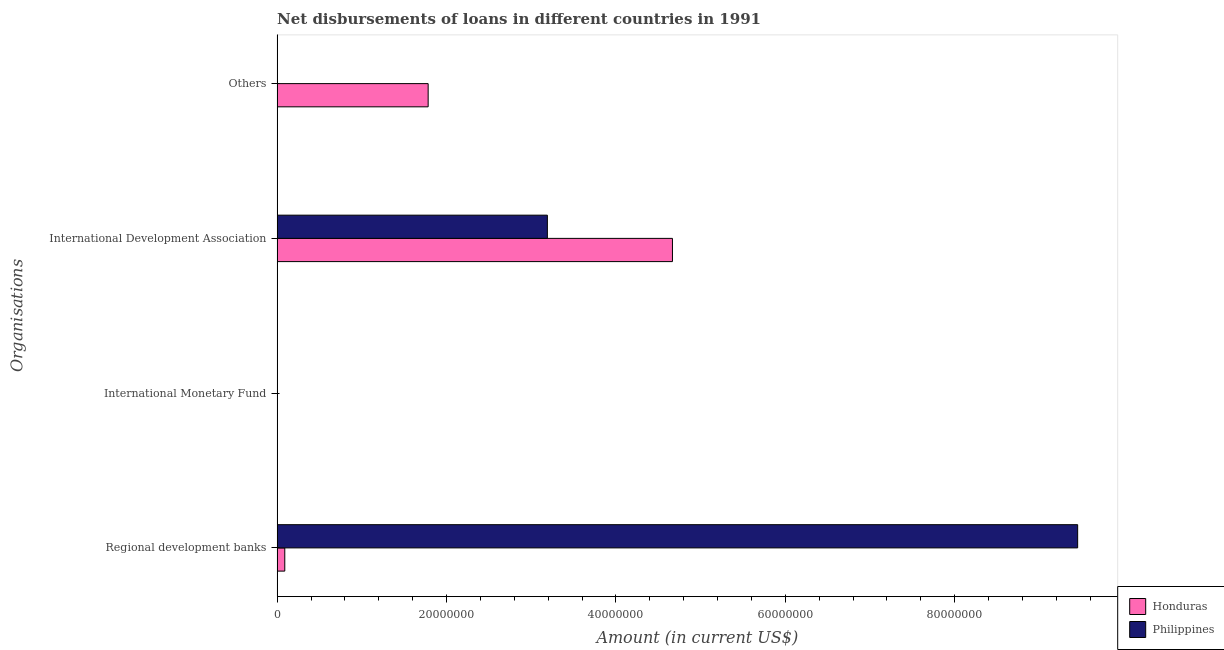How many different coloured bars are there?
Your answer should be compact. 2. Are the number of bars per tick equal to the number of legend labels?
Ensure brevity in your answer.  No. Are the number of bars on each tick of the Y-axis equal?
Your response must be concise. No. How many bars are there on the 3rd tick from the top?
Provide a succinct answer. 0. What is the label of the 4th group of bars from the top?
Keep it short and to the point. Regional development banks. What is the amount of loan disimbursed by international development association in Honduras?
Ensure brevity in your answer.  4.67e+07. Across all countries, what is the maximum amount of loan disimbursed by regional development banks?
Offer a very short reply. 9.45e+07. Across all countries, what is the minimum amount of loan disimbursed by international monetary fund?
Offer a terse response. 0. In which country was the amount of loan disimbursed by international development association maximum?
Your answer should be very brief. Honduras. What is the total amount of loan disimbursed by international monetary fund in the graph?
Provide a short and direct response. 0. What is the difference between the amount of loan disimbursed by regional development banks in Honduras and that in Philippines?
Provide a succinct answer. -9.36e+07. What is the difference between the amount of loan disimbursed by international monetary fund in Honduras and the amount of loan disimbursed by international development association in Philippines?
Ensure brevity in your answer.  -3.19e+07. What is the average amount of loan disimbursed by other organisations per country?
Provide a short and direct response. 8.92e+06. What is the difference between the amount of loan disimbursed by international development association and amount of loan disimbursed by regional development banks in Honduras?
Your response must be concise. 4.58e+07. What is the ratio of the amount of loan disimbursed by international development association in Honduras to that in Philippines?
Ensure brevity in your answer.  1.46. Is the amount of loan disimbursed by international development association in Honduras less than that in Philippines?
Ensure brevity in your answer.  No. Is the difference between the amount of loan disimbursed by international development association in Honduras and Philippines greater than the difference between the amount of loan disimbursed by regional development banks in Honduras and Philippines?
Offer a very short reply. Yes. What is the difference between the highest and the second highest amount of loan disimbursed by international development association?
Ensure brevity in your answer.  1.48e+07. What is the difference between the highest and the lowest amount of loan disimbursed by international development association?
Your answer should be very brief. 1.48e+07. In how many countries, is the amount of loan disimbursed by other organisations greater than the average amount of loan disimbursed by other organisations taken over all countries?
Offer a very short reply. 1. How many bars are there?
Your answer should be very brief. 5. Are all the bars in the graph horizontal?
Provide a succinct answer. Yes. Are the values on the major ticks of X-axis written in scientific E-notation?
Offer a very short reply. No. Does the graph contain any zero values?
Your answer should be compact. Yes. Does the graph contain grids?
Make the answer very short. No. How many legend labels are there?
Your answer should be very brief. 2. What is the title of the graph?
Ensure brevity in your answer.  Net disbursements of loans in different countries in 1991. Does "Spain" appear as one of the legend labels in the graph?
Make the answer very short. No. What is the label or title of the X-axis?
Keep it short and to the point. Amount (in current US$). What is the label or title of the Y-axis?
Offer a very short reply. Organisations. What is the Amount (in current US$) of Honduras in Regional development banks?
Ensure brevity in your answer.  9.04e+05. What is the Amount (in current US$) of Philippines in Regional development banks?
Ensure brevity in your answer.  9.45e+07. What is the Amount (in current US$) of Philippines in International Monetary Fund?
Provide a succinct answer. 0. What is the Amount (in current US$) of Honduras in International Development Association?
Your answer should be compact. 4.67e+07. What is the Amount (in current US$) in Philippines in International Development Association?
Ensure brevity in your answer.  3.19e+07. What is the Amount (in current US$) in Honduras in Others?
Offer a terse response. 1.78e+07. Across all Organisations, what is the maximum Amount (in current US$) of Honduras?
Your answer should be very brief. 4.67e+07. Across all Organisations, what is the maximum Amount (in current US$) in Philippines?
Offer a very short reply. 9.45e+07. Across all Organisations, what is the minimum Amount (in current US$) in Honduras?
Your answer should be very brief. 0. What is the total Amount (in current US$) in Honduras in the graph?
Offer a very short reply. 6.54e+07. What is the total Amount (in current US$) in Philippines in the graph?
Offer a terse response. 1.26e+08. What is the difference between the Amount (in current US$) in Honduras in Regional development banks and that in International Development Association?
Ensure brevity in your answer.  -4.58e+07. What is the difference between the Amount (in current US$) in Philippines in Regional development banks and that in International Development Association?
Keep it short and to the point. 6.26e+07. What is the difference between the Amount (in current US$) of Honduras in Regional development banks and that in Others?
Provide a short and direct response. -1.69e+07. What is the difference between the Amount (in current US$) in Honduras in International Development Association and that in Others?
Offer a very short reply. 2.88e+07. What is the difference between the Amount (in current US$) of Honduras in Regional development banks and the Amount (in current US$) of Philippines in International Development Association?
Offer a very short reply. -3.10e+07. What is the average Amount (in current US$) of Honduras per Organisations?
Offer a very short reply. 1.64e+07. What is the average Amount (in current US$) of Philippines per Organisations?
Your answer should be very brief. 3.16e+07. What is the difference between the Amount (in current US$) of Honduras and Amount (in current US$) of Philippines in Regional development banks?
Your response must be concise. -9.36e+07. What is the difference between the Amount (in current US$) of Honduras and Amount (in current US$) of Philippines in International Development Association?
Ensure brevity in your answer.  1.48e+07. What is the ratio of the Amount (in current US$) in Honduras in Regional development banks to that in International Development Association?
Provide a short and direct response. 0.02. What is the ratio of the Amount (in current US$) in Philippines in Regional development banks to that in International Development Association?
Your response must be concise. 2.96. What is the ratio of the Amount (in current US$) of Honduras in Regional development banks to that in Others?
Ensure brevity in your answer.  0.05. What is the ratio of the Amount (in current US$) in Honduras in International Development Association to that in Others?
Ensure brevity in your answer.  2.62. What is the difference between the highest and the second highest Amount (in current US$) in Honduras?
Provide a short and direct response. 2.88e+07. What is the difference between the highest and the lowest Amount (in current US$) in Honduras?
Your answer should be very brief. 4.67e+07. What is the difference between the highest and the lowest Amount (in current US$) of Philippines?
Provide a short and direct response. 9.45e+07. 